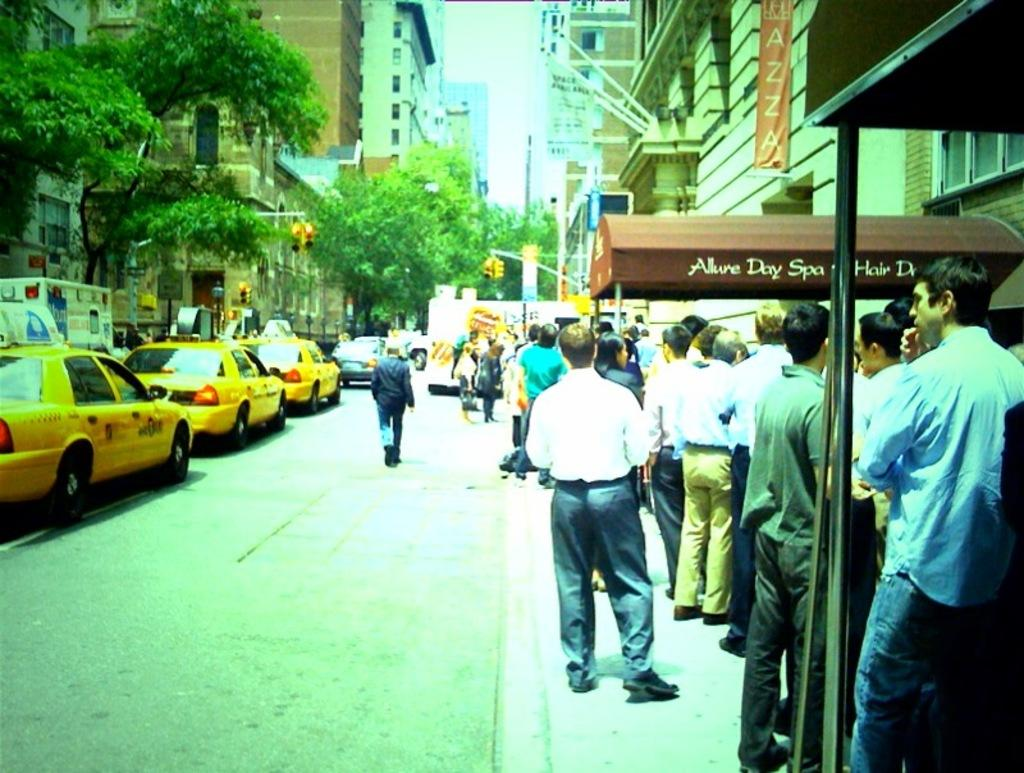<image>
Create a compact narrative representing the image presented. the word allure on a red awning that is outside 